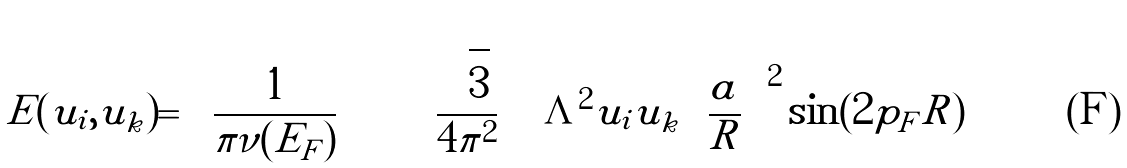<formula> <loc_0><loc_0><loc_500><loc_500>E ( u _ { i } , u _ { k } ) = \left ( \frac { 1 } { \pi \nu ( E _ { F } ) } \, \right ) \left \{ \left ( \frac { \sqrt { 3 } } { 4 \pi ^ { 2 } } \, \right ) \Lambda ^ { 2 } \tilde { u } _ { i } \tilde { u } _ { k } \left ( \frac { a } { R } \, \right ) ^ { 2 } \sin ( 2 p _ { F } R ) \right \}</formula> 